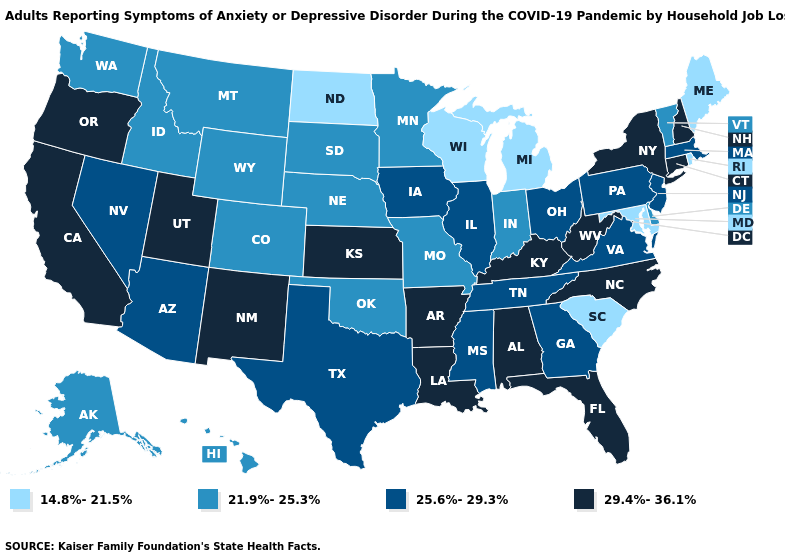What is the value of Indiana?
Short answer required. 21.9%-25.3%. Name the states that have a value in the range 25.6%-29.3%?
Give a very brief answer. Arizona, Georgia, Illinois, Iowa, Massachusetts, Mississippi, Nevada, New Jersey, Ohio, Pennsylvania, Tennessee, Texas, Virginia. Name the states that have a value in the range 25.6%-29.3%?
Concise answer only. Arizona, Georgia, Illinois, Iowa, Massachusetts, Mississippi, Nevada, New Jersey, Ohio, Pennsylvania, Tennessee, Texas, Virginia. Name the states that have a value in the range 25.6%-29.3%?
Concise answer only. Arizona, Georgia, Illinois, Iowa, Massachusetts, Mississippi, Nevada, New Jersey, Ohio, Pennsylvania, Tennessee, Texas, Virginia. Which states have the lowest value in the West?
Short answer required. Alaska, Colorado, Hawaii, Idaho, Montana, Washington, Wyoming. How many symbols are there in the legend?
Be succinct. 4. Among the states that border Colorado , which have the lowest value?
Keep it brief. Nebraska, Oklahoma, Wyoming. Among the states that border Montana , does North Dakota have the lowest value?
Answer briefly. Yes. Does Missouri have the same value as South Dakota?
Give a very brief answer. Yes. Does Connecticut have the highest value in the USA?
Quick response, please. Yes. What is the value of Kentucky?
Give a very brief answer. 29.4%-36.1%. Does South Dakota have a lower value than California?
Concise answer only. Yes. What is the highest value in states that border New Jersey?
Write a very short answer. 29.4%-36.1%. What is the value of Kentucky?
Give a very brief answer. 29.4%-36.1%. What is the value of Delaware?
Keep it brief. 21.9%-25.3%. 